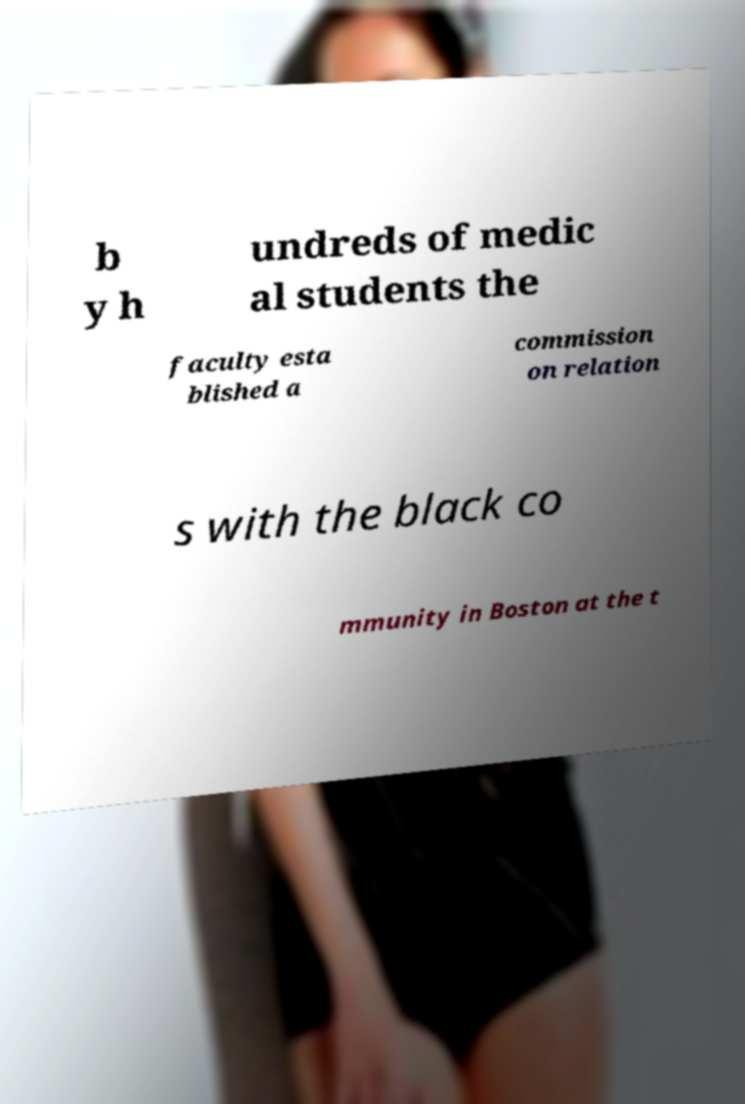Please read and relay the text visible in this image. What does it say? b y h undreds of medic al students the faculty esta blished a commission on relation s with the black co mmunity in Boston at the t 